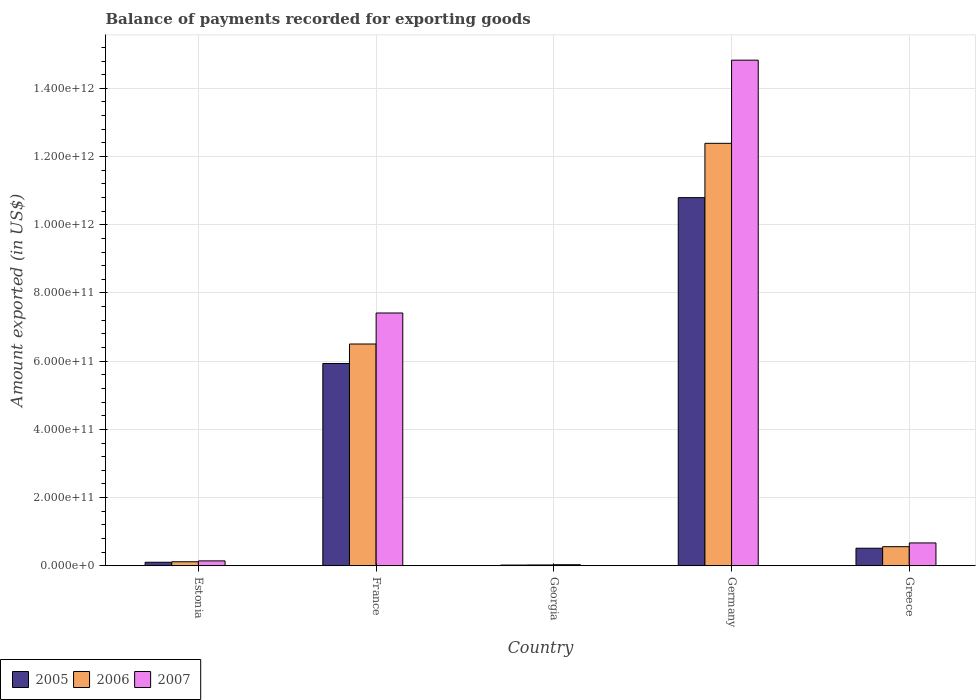How many different coloured bars are there?
Keep it short and to the point. 3. Are the number of bars per tick equal to the number of legend labels?
Your answer should be compact. Yes. How many bars are there on the 2nd tick from the left?
Your answer should be very brief. 3. How many bars are there on the 4th tick from the right?
Your answer should be compact. 3. In how many cases, is the number of bars for a given country not equal to the number of legend labels?
Offer a terse response. 0. What is the amount exported in 2006 in Georgia?
Your answer should be compact. 2.50e+09. Across all countries, what is the maximum amount exported in 2007?
Offer a very short reply. 1.48e+12. Across all countries, what is the minimum amount exported in 2006?
Your answer should be compact. 2.50e+09. In which country was the amount exported in 2005 minimum?
Provide a succinct answer. Georgia. What is the total amount exported in 2005 in the graph?
Offer a terse response. 1.74e+12. What is the difference between the amount exported in 2006 in France and that in Greece?
Your response must be concise. 5.94e+11. What is the difference between the amount exported in 2007 in Greece and the amount exported in 2005 in France?
Make the answer very short. -5.26e+11. What is the average amount exported in 2007 per country?
Offer a terse response. 4.62e+11. What is the difference between the amount exported of/in 2005 and amount exported of/in 2006 in Estonia?
Provide a succinct answer. -1.46e+09. In how many countries, is the amount exported in 2006 greater than 800000000000 US$?
Offer a very short reply. 1. What is the ratio of the amount exported in 2006 in Georgia to that in Greece?
Keep it short and to the point. 0.04. Is the amount exported in 2006 in Estonia less than that in Georgia?
Your answer should be very brief. No. What is the difference between the highest and the second highest amount exported in 2005?
Give a very brief answer. 4.86e+11. What is the difference between the highest and the lowest amount exported in 2007?
Your answer should be compact. 1.48e+12. In how many countries, is the amount exported in 2005 greater than the average amount exported in 2005 taken over all countries?
Provide a short and direct response. 2. What does the 1st bar from the right in Georgia represents?
Your answer should be compact. 2007. Are all the bars in the graph horizontal?
Make the answer very short. No. What is the difference between two consecutive major ticks on the Y-axis?
Your answer should be compact. 2.00e+11. Does the graph contain any zero values?
Your answer should be very brief. No. Does the graph contain grids?
Provide a short and direct response. Yes. Where does the legend appear in the graph?
Your answer should be very brief. Bottom left. How many legend labels are there?
Keep it short and to the point. 3. How are the legend labels stacked?
Give a very brief answer. Horizontal. What is the title of the graph?
Give a very brief answer. Balance of payments recorded for exporting goods. What is the label or title of the Y-axis?
Your response must be concise. Amount exported (in US$). What is the Amount exported (in US$) in 2005 in Estonia?
Keep it short and to the point. 1.04e+1. What is the Amount exported (in US$) in 2006 in Estonia?
Keep it short and to the point. 1.18e+1. What is the Amount exported (in US$) of 2007 in Estonia?
Provide a short and direct response. 1.44e+1. What is the Amount exported (in US$) in 2005 in France?
Your answer should be compact. 5.93e+11. What is the Amount exported (in US$) of 2006 in France?
Your answer should be very brief. 6.50e+11. What is the Amount exported (in US$) in 2007 in France?
Make the answer very short. 7.41e+11. What is the Amount exported (in US$) of 2005 in Georgia?
Your answer should be compact. 2.15e+09. What is the Amount exported (in US$) of 2006 in Georgia?
Give a very brief answer. 2.50e+09. What is the Amount exported (in US$) of 2007 in Georgia?
Ensure brevity in your answer.  3.16e+09. What is the Amount exported (in US$) of 2005 in Germany?
Provide a succinct answer. 1.08e+12. What is the Amount exported (in US$) in 2006 in Germany?
Make the answer very short. 1.24e+12. What is the Amount exported (in US$) in 2007 in Germany?
Keep it short and to the point. 1.48e+12. What is the Amount exported (in US$) in 2005 in Greece?
Your response must be concise. 5.15e+1. What is the Amount exported (in US$) of 2006 in Greece?
Your answer should be very brief. 5.60e+1. What is the Amount exported (in US$) of 2007 in Greece?
Your answer should be very brief. 6.70e+1. Across all countries, what is the maximum Amount exported (in US$) of 2005?
Offer a very short reply. 1.08e+12. Across all countries, what is the maximum Amount exported (in US$) in 2006?
Offer a very short reply. 1.24e+12. Across all countries, what is the maximum Amount exported (in US$) in 2007?
Your answer should be compact. 1.48e+12. Across all countries, what is the minimum Amount exported (in US$) of 2005?
Ensure brevity in your answer.  2.15e+09. Across all countries, what is the minimum Amount exported (in US$) in 2006?
Make the answer very short. 2.50e+09. Across all countries, what is the minimum Amount exported (in US$) of 2007?
Provide a short and direct response. 3.16e+09. What is the total Amount exported (in US$) of 2005 in the graph?
Provide a short and direct response. 1.74e+12. What is the total Amount exported (in US$) of 2006 in the graph?
Offer a terse response. 1.96e+12. What is the total Amount exported (in US$) in 2007 in the graph?
Give a very brief answer. 2.31e+12. What is the difference between the Amount exported (in US$) of 2005 in Estonia and that in France?
Keep it short and to the point. -5.83e+11. What is the difference between the Amount exported (in US$) of 2006 in Estonia and that in France?
Provide a succinct answer. -6.38e+11. What is the difference between the Amount exported (in US$) in 2007 in Estonia and that in France?
Keep it short and to the point. -7.27e+11. What is the difference between the Amount exported (in US$) of 2005 in Estonia and that in Georgia?
Provide a succinct answer. 8.22e+09. What is the difference between the Amount exported (in US$) of 2006 in Estonia and that in Georgia?
Make the answer very short. 9.33e+09. What is the difference between the Amount exported (in US$) of 2007 in Estonia and that in Georgia?
Give a very brief answer. 1.12e+1. What is the difference between the Amount exported (in US$) of 2005 in Estonia and that in Germany?
Provide a short and direct response. -1.07e+12. What is the difference between the Amount exported (in US$) in 2006 in Estonia and that in Germany?
Keep it short and to the point. -1.23e+12. What is the difference between the Amount exported (in US$) of 2007 in Estonia and that in Germany?
Keep it short and to the point. -1.47e+12. What is the difference between the Amount exported (in US$) of 2005 in Estonia and that in Greece?
Offer a very short reply. -4.12e+1. What is the difference between the Amount exported (in US$) of 2006 in Estonia and that in Greece?
Keep it short and to the point. -4.42e+1. What is the difference between the Amount exported (in US$) of 2007 in Estonia and that in Greece?
Your answer should be very brief. -5.27e+1. What is the difference between the Amount exported (in US$) in 2005 in France and that in Georgia?
Make the answer very short. 5.91e+11. What is the difference between the Amount exported (in US$) in 2006 in France and that in Georgia?
Your answer should be compact. 6.48e+11. What is the difference between the Amount exported (in US$) of 2007 in France and that in Georgia?
Your answer should be compact. 7.38e+11. What is the difference between the Amount exported (in US$) of 2005 in France and that in Germany?
Provide a short and direct response. -4.86e+11. What is the difference between the Amount exported (in US$) in 2006 in France and that in Germany?
Your answer should be very brief. -5.88e+11. What is the difference between the Amount exported (in US$) in 2007 in France and that in Germany?
Offer a terse response. -7.41e+11. What is the difference between the Amount exported (in US$) in 2005 in France and that in Greece?
Offer a terse response. 5.42e+11. What is the difference between the Amount exported (in US$) of 2006 in France and that in Greece?
Ensure brevity in your answer.  5.94e+11. What is the difference between the Amount exported (in US$) in 2007 in France and that in Greece?
Provide a short and direct response. 6.74e+11. What is the difference between the Amount exported (in US$) of 2005 in Georgia and that in Germany?
Give a very brief answer. -1.08e+12. What is the difference between the Amount exported (in US$) in 2006 in Georgia and that in Germany?
Your answer should be very brief. -1.24e+12. What is the difference between the Amount exported (in US$) of 2007 in Georgia and that in Germany?
Your answer should be compact. -1.48e+12. What is the difference between the Amount exported (in US$) in 2005 in Georgia and that in Greece?
Offer a very short reply. -4.94e+1. What is the difference between the Amount exported (in US$) in 2006 in Georgia and that in Greece?
Give a very brief answer. -5.35e+1. What is the difference between the Amount exported (in US$) of 2007 in Georgia and that in Greece?
Ensure brevity in your answer.  -6.39e+1. What is the difference between the Amount exported (in US$) of 2005 in Germany and that in Greece?
Keep it short and to the point. 1.03e+12. What is the difference between the Amount exported (in US$) of 2006 in Germany and that in Greece?
Ensure brevity in your answer.  1.18e+12. What is the difference between the Amount exported (in US$) of 2007 in Germany and that in Greece?
Make the answer very short. 1.42e+12. What is the difference between the Amount exported (in US$) of 2005 in Estonia and the Amount exported (in US$) of 2006 in France?
Your response must be concise. -6.40e+11. What is the difference between the Amount exported (in US$) of 2005 in Estonia and the Amount exported (in US$) of 2007 in France?
Provide a succinct answer. -7.31e+11. What is the difference between the Amount exported (in US$) of 2006 in Estonia and the Amount exported (in US$) of 2007 in France?
Keep it short and to the point. -7.29e+11. What is the difference between the Amount exported (in US$) in 2005 in Estonia and the Amount exported (in US$) in 2006 in Georgia?
Offer a terse response. 7.87e+09. What is the difference between the Amount exported (in US$) in 2005 in Estonia and the Amount exported (in US$) in 2007 in Georgia?
Offer a terse response. 7.21e+09. What is the difference between the Amount exported (in US$) of 2006 in Estonia and the Amount exported (in US$) of 2007 in Georgia?
Keep it short and to the point. 8.67e+09. What is the difference between the Amount exported (in US$) of 2005 in Estonia and the Amount exported (in US$) of 2006 in Germany?
Your response must be concise. -1.23e+12. What is the difference between the Amount exported (in US$) of 2005 in Estonia and the Amount exported (in US$) of 2007 in Germany?
Your answer should be compact. -1.47e+12. What is the difference between the Amount exported (in US$) of 2006 in Estonia and the Amount exported (in US$) of 2007 in Germany?
Provide a short and direct response. -1.47e+12. What is the difference between the Amount exported (in US$) in 2005 in Estonia and the Amount exported (in US$) in 2006 in Greece?
Keep it short and to the point. -4.57e+1. What is the difference between the Amount exported (in US$) of 2005 in Estonia and the Amount exported (in US$) of 2007 in Greece?
Provide a short and direct response. -5.67e+1. What is the difference between the Amount exported (in US$) in 2006 in Estonia and the Amount exported (in US$) in 2007 in Greece?
Give a very brief answer. -5.52e+1. What is the difference between the Amount exported (in US$) in 2005 in France and the Amount exported (in US$) in 2006 in Georgia?
Provide a succinct answer. 5.91e+11. What is the difference between the Amount exported (in US$) of 2005 in France and the Amount exported (in US$) of 2007 in Georgia?
Ensure brevity in your answer.  5.90e+11. What is the difference between the Amount exported (in US$) of 2006 in France and the Amount exported (in US$) of 2007 in Georgia?
Make the answer very short. 6.47e+11. What is the difference between the Amount exported (in US$) of 2005 in France and the Amount exported (in US$) of 2006 in Germany?
Offer a very short reply. -6.46e+11. What is the difference between the Amount exported (in US$) in 2005 in France and the Amount exported (in US$) in 2007 in Germany?
Keep it short and to the point. -8.89e+11. What is the difference between the Amount exported (in US$) in 2006 in France and the Amount exported (in US$) in 2007 in Germany?
Offer a terse response. -8.32e+11. What is the difference between the Amount exported (in US$) of 2005 in France and the Amount exported (in US$) of 2006 in Greece?
Offer a terse response. 5.37e+11. What is the difference between the Amount exported (in US$) of 2005 in France and the Amount exported (in US$) of 2007 in Greece?
Give a very brief answer. 5.26e+11. What is the difference between the Amount exported (in US$) in 2006 in France and the Amount exported (in US$) in 2007 in Greece?
Make the answer very short. 5.83e+11. What is the difference between the Amount exported (in US$) in 2005 in Georgia and the Amount exported (in US$) in 2006 in Germany?
Offer a very short reply. -1.24e+12. What is the difference between the Amount exported (in US$) of 2005 in Georgia and the Amount exported (in US$) of 2007 in Germany?
Give a very brief answer. -1.48e+12. What is the difference between the Amount exported (in US$) of 2006 in Georgia and the Amount exported (in US$) of 2007 in Germany?
Your answer should be compact. -1.48e+12. What is the difference between the Amount exported (in US$) of 2005 in Georgia and the Amount exported (in US$) of 2006 in Greece?
Give a very brief answer. -5.39e+1. What is the difference between the Amount exported (in US$) of 2005 in Georgia and the Amount exported (in US$) of 2007 in Greece?
Ensure brevity in your answer.  -6.49e+1. What is the difference between the Amount exported (in US$) of 2006 in Georgia and the Amount exported (in US$) of 2007 in Greece?
Ensure brevity in your answer.  -6.45e+1. What is the difference between the Amount exported (in US$) of 2005 in Germany and the Amount exported (in US$) of 2006 in Greece?
Provide a short and direct response. 1.02e+12. What is the difference between the Amount exported (in US$) of 2005 in Germany and the Amount exported (in US$) of 2007 in Greece?
Your answer should be compact. 1.01e+12. What is the difference between the Amount exported (in US$) in 2006 in Germany and the Amount exported (in US$) in 2007 in Greece?
Your answer should be very brief. 1.17e+12. What is the average Amount exported (in US$) in 2005 per country?
Offer a terse response. 3.47e+11. What is the average Amount exported (in US$) in 2006 per country?
Your response must be concise. 3.92e+11. What is the average Amount exported (in US$) in 2007 per country?
Provide a short and direct response. 4.62e+11. What is the difference between the Amount exported (in US$) in 2005 and Amount exported (in US$) in 2006 in Estonia?
Make the answer very short. -1.46e+09. What is the difference between the Amount exported (in US$) in 2005 and Amount exported (in US$) in 2007 in Estonia?
Offer a very short reply. -4.01e+09. What is the difference between the Amount exported (in US$) in 2006 and Amount exported (in US$) in 2007 in Estonia?
Your answer should be compact. -2.55e+09. What is the difference between the Amount exported (in US$) of 2005 and Amount exported (in US$) of 2006 in France?
Your answer should be compact. -5.71e+1. What is the difference between the Amount exported (in US$) of 2005 and Amount exported (in US$) of 2007 in France?
Offer a terse response. -1.48e+11. What is the difference between the Amount exported (in US$) of 2006 and Amount exported (in US$) of 2007 in France?
Your answer should be very brief. -9.10e+1. What is the difference between the Amount exported (in US$) in 2005 and Amount exported (in US$) in 2006 in Georgia?
Give a very brief answer. -3.48e+08. What is the difference between the Amount exported (in US$) in 2005 and Amount exported (in US$) in 2007 in Georgia?
Provide a short and direct response. -1.01e+09. What is the difference between the Amount exported (in US$) in 2006 and Amount exported (in US$) in 2007 in Georgia?
Your response must be concise. -6.63e+08. What is the difference between the Amount exported (in US$) in 2005 and Amount exported (in US$) in 2006 in Germany?
Ensure brevity in your answer.  -1.59e+11. What is the difference between the Amount exported (in US$) of 2005 and Amount exported (in US$) of 2007 in Germany?
Offer a very short reply. -4.03e+11. What is the difference between the Amount exported (in US$) in 2006 and Amount exported (in US$) in 2007 in Germany?
Provide a short and direct response. -2.44e+11. What is the difference between the Amount exported (in US$) in 2005 and Amount exported (in US$) in 2006 in Greece?
Your response must be concise. -4.51e+09. What is the difference between the Amount exported (in US$) of 2005 and Amount exported (in US$) of 2007 in Greece?
Your answer should be compact. -1.55e+1. What is the difference between the Amount exported (in US$) in 2006 and Amount exported (in US$) in 2007 in Greece?
Give a very brief answer. -1.10e+1. What is the ratio of the Amount exported (in US$) in 2005 in Estonia to that in France?
Offer a very short reply. 0.02. What is the ratio of the Amount exported (in US$) of 2006 in Estonia to that in France?
Keep it short and to the point. 0.02. What is the ratio of the Amount exported (in US$) of 2007 in Estonia to that in France?
Provide a short and direct response. 0.02. What is the ratio of the Amount exported (in US$) of 2005 in Estonia to that in Georgia?
Keep it short and to the point. 4.82. What is the ratio of the Amount exported (in US$) in 2006 in Estonia to that in Georgia?
Your answer should be compact. 4.73. What is the ratio of the Amount exported (in US$) in 2007 in Estonia to that in Georgia?
Offer a very short reply. 4.55. What is the ratio of the Amount exported (in US$) in 2005 in Estonia to that in Germany?
Keep it short and to the point. 0.01. What is the ratio of the Amount exported (in US$) in 2006 in Estonia to that in Germany?
Ensure brevity in your answer.  0.01. What is the ratio of the Amount exported (in US$) of 2007 in Estonia to that in Germany?
Give a very brief answer. 0.01. What is the ratio of the Amount exported (in US$) of 2005 in Estonia to that in Greece?
Keep it short and to the point. 0.2. What is the ratio of the Amount exported (in US$) in 2006 in Estonia to that in Greece?
Give a very brief answer. 0.21. What is the ratio of the Amount exported (in US$) of 2007 in Estonia to that in Greece?
Ensure brevity in your answer.  0.21. What is the ratio of the Amount exported (in US$) in 2005 in France to that in Georgia?
Provide a short and direct response. 275.66. What is the ratio of the Amount exported (in US$) of 2006 in France to that in Georgia?
Provide a short and direct response. 260.12. What is the ratio of the Amount exported (in US$) in 2007 in France to that in Georgia?
Offer a terse response. 234.37. What is the ratio of the Amount exported (in US$) of 2005 in France to that in Germany?
Offer a very short reply. 0.55. What is the ratio of the Amount exported (in US$) of 2006 in France to that in Germany?
Provide a succinct answer. 0.53. What is the ratio of the Amount exported (in US$) in 2007 in France to that in Germany?
Your answer should be very brief. 0.5. What is the ratio of the Amount exported (in US$) of 2005 in France to that in Greece?
Offer a very short reply. 11.51. What is the ratio of the Amount exported (in US$) of 2006 in France to that in Greece?
Ensure brevity in your answer.  11.61. What is the ratio of the Amount exported (in US$) in 2007 in France to that in Greece?
Your answer should be very brief. 11.06. What is the ratio of the Amount exported (in US$) in 2005 in Georgia to that in Germany?
Your response must be concise. 0. What is the ratio of the Amount exported (in US$) in 2006 in Georgia to that in Germany?
Your answer should be compact. 0. What is the ratio of the Amount exported (in US$) in 2007 in Georgia to that in Germany?
Provide a succinct answer. 0. What is the ratio of the Amount exported (in US$) in 2005 in Georgia to that in Greece?
Give a very brief answer. 0.04. What is the ratio of the Amount exported (in US$) in 2006 in Georgia to that in Greece?
Keep it short and to the point. 0.04. What is the ratio of the Amount exported (in US$) in 2007 in Georgia to that in Greece?
Offer a terse response. 0.05. What is the ratio of the Amount exported (in US$) in 2005 in Germany to that in Greece?
Your answer should be compact. 20.95. What is the ratio of the Amount exported (in US$) in 2006 in Germany to that in Greece?
Offer a terse response. 22.11. What is the ratio of the Amount exported (in US$) of 2007 in Germany to that in Greece?
Offer a very short reply. 22.11. What is the difference between the highest and the second highest Amount exported (in US$) in 2005?
Keep it short and to the point. 4.86e+11. What is the difference between the highest and the second highest Amount exported (in US$) of 2006?
Keep it short and to the point. 5.88e+11. What is the difference between the highest and the second highest Amount exported (in US$) of 2007?
Offer a terse response. 7.41e+11. What is the difference between the highest and the lowest Amount exported (in US$) of 2005?
Your response must be concise. 1.08e+12. What is the difference between the highest and the lowest Amount exported (in US$) in 2006?
Your response must be concise. 1.24e+12. What is the difference between the highest and the lowest Amount exported (in US$) in 2007?
Provide a short and direct response. 1.48e+12. 